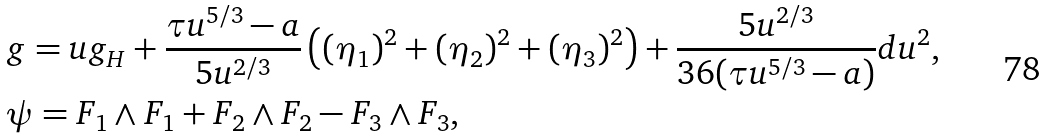Convert formula to latex. <formula><loc_0><loc_0><loc_500><loc_500>& g = u g _ { H } + \frac { \tau u ^ { 5 / 3 } - a } { 5 u ^ { 2 / 3 } } \left ( ( \eta _ { 1 } ) ^ { 2 } + ( \eta _ { 2 } ) ^ { 2 } + ( \eta _ { 3 } ) ^ { 2 } \right ) + \frac { 5 u ^ { 2 / 3 } } { 3 6 ( \tau u ^ { 5 / 3 } - a ) } d u ^ { 2 } , \\ & \psi = F _ { 1 } \wedge F _ { 1 } + F _ { 2 } \wedge F _ { 2 } - F _ { 3 } \wedge F _ { 3 } ,</formula> 